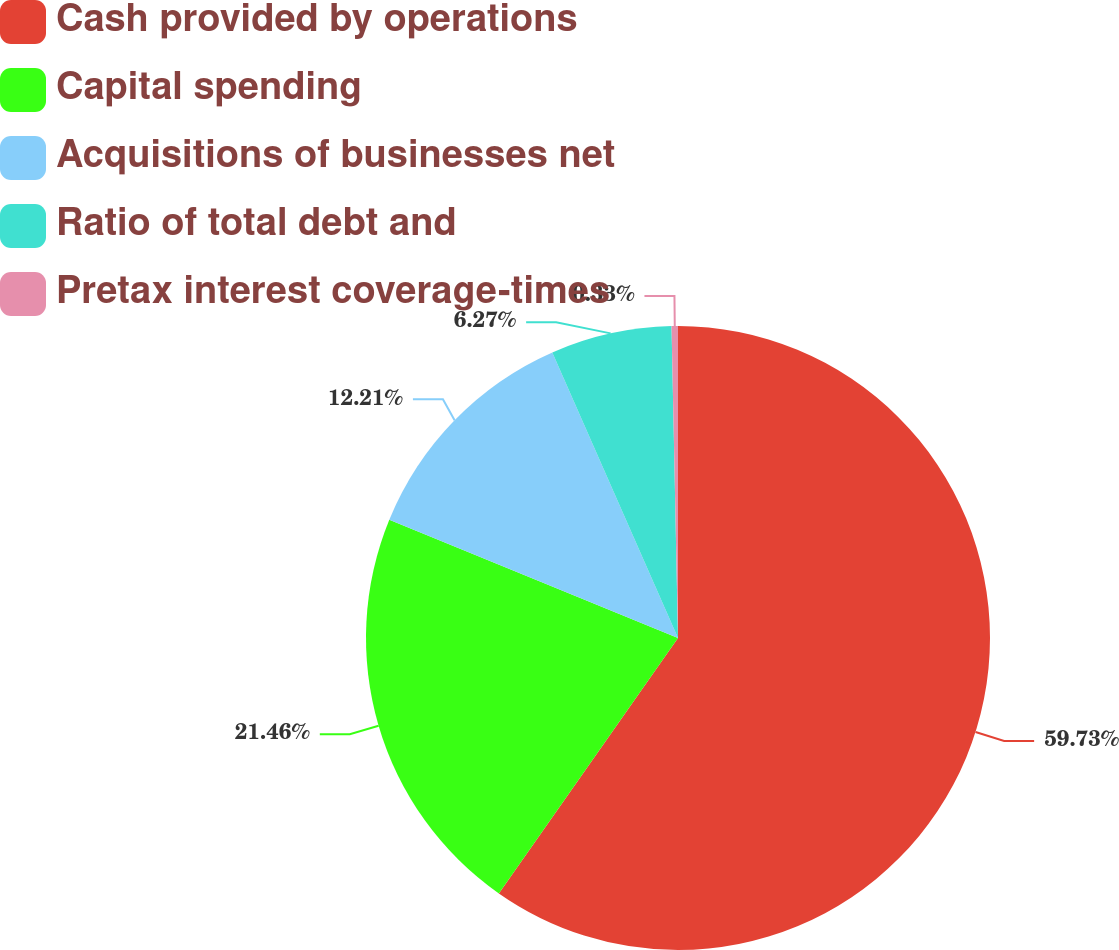Convert chart to OTSL. <chart><loc_0><loc_0><loc_500><loc_500><pie_chart><fcel>Cash provided by operations<fcel>Capital spending<fcel>Acquisitions of businesses net<fcel>Ratio of total debt and<fcel>Pretax interest coverage-times<nl><fcel>59.74%<fcel>21.46%<fcel>12.21%<fcel>6.27%<fcel>0.33%<nl></chart> 